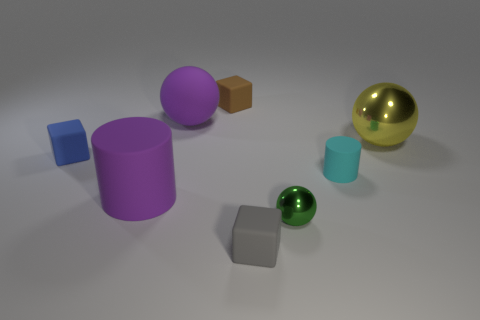Subtract all big spheres. How many spheres are left? 1 Add 1 big purple cylinders. How many objects exist? 9 Subtract all brown balls. Subtract all green cylinders. How many balls are left? 3 Subtract all blocks. How many objects are left? 5 Add 8 blue rubber balls. How many blue rubber balls exist? 8 Subtract 0 blue cylinders. How many objects are left? 8 Subtract all big green matte cylinders. Subtract all brown cubes. How many objects are left? 7 Add 7 small green metallic spheres. How many small green metallic spheres are left? 8 